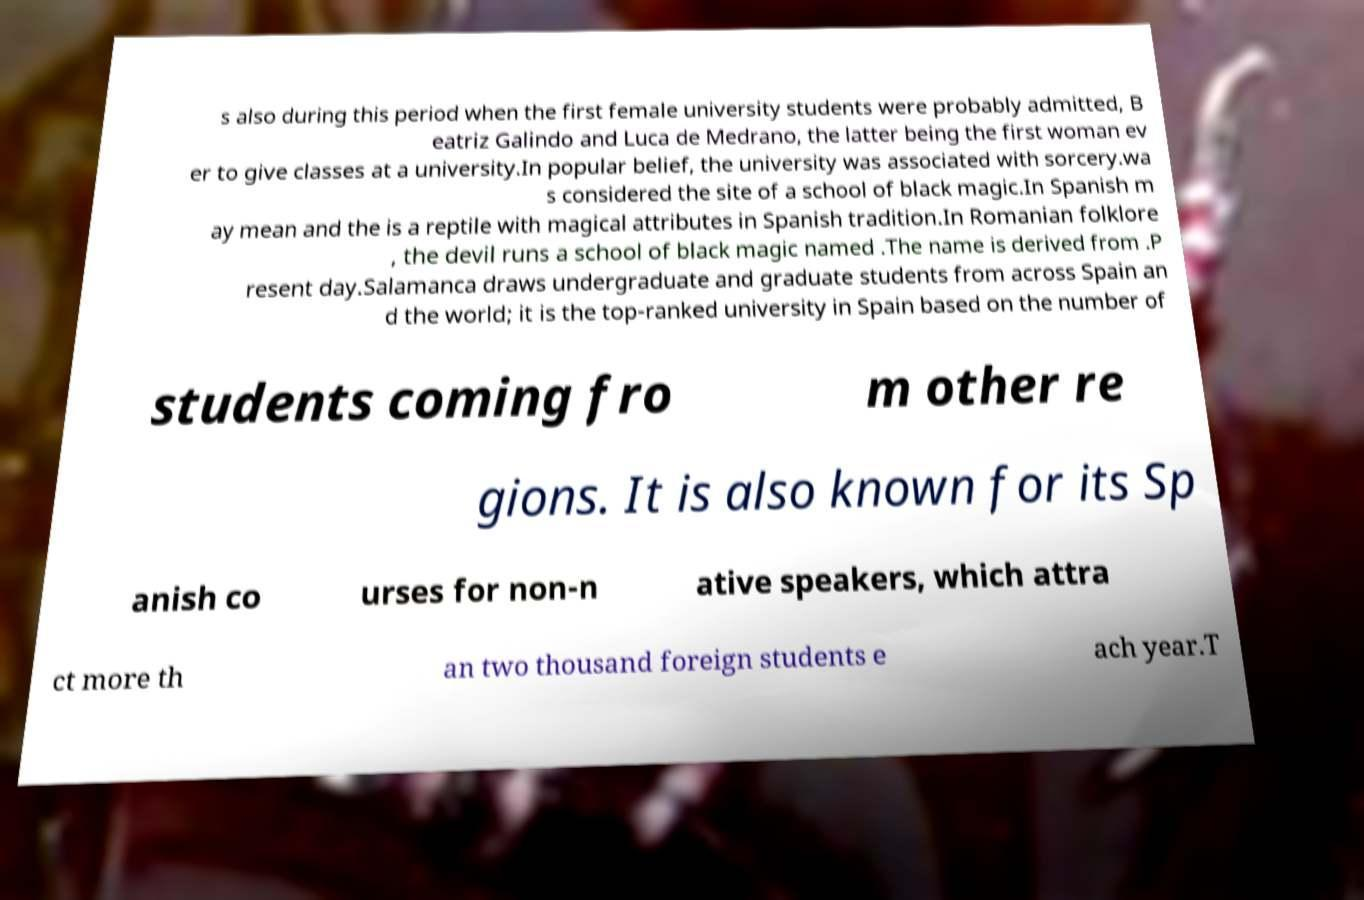I need the written content from this picture converted into text. Can you do that? s also during this period when the first female university students were probably admitted, B eatriz Galindo and Luca de Medrano, the latter being the first woman ev er to give classes at a university.In popular belief, the university was associated with sorcery.wa s considered the site of a school of black magic.In Spanish m ay mean and the is a reptile with magical attributes in Spanish tradition.In Romanian folklore , the devil runs a school of black magic named .The name is derived from .P resent day.Salamanca draws undergraduate and graduate students from across Spain an d the world; it is the top-ranked university in Spain based on the number of students coming fro m other re gions. It is also known for its Sp anish co urses for non-n ative speakers, which attra ct more th an two thousand foreign students e ach year.T 